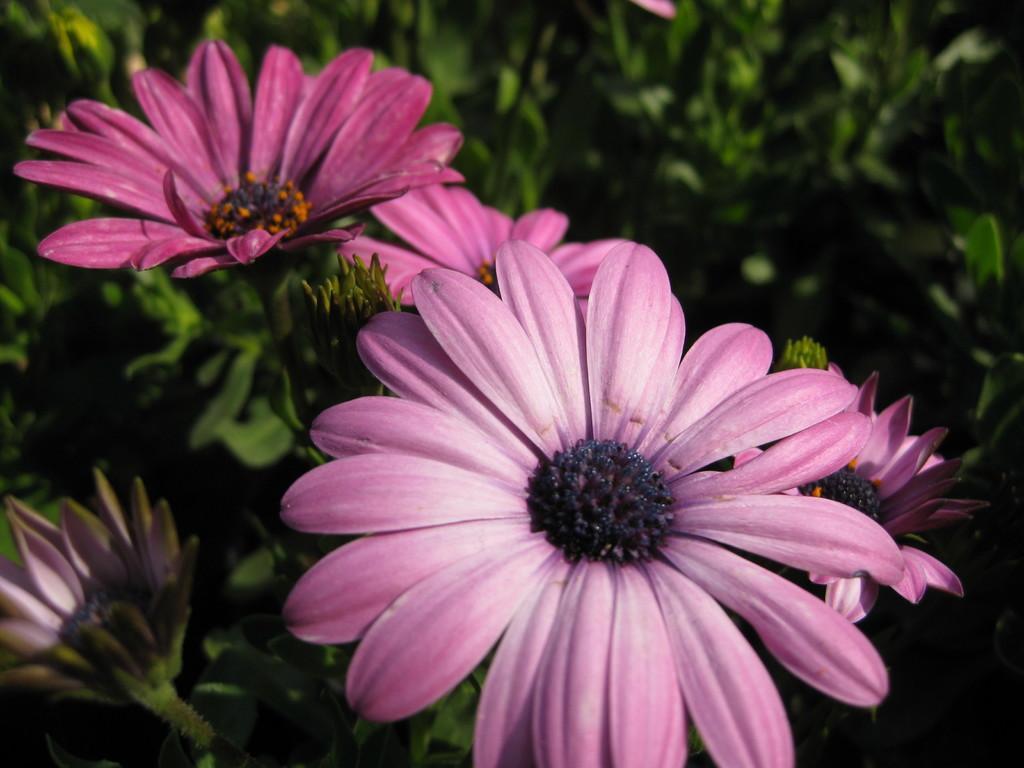Please provide a concise description of this image. In this image we can see flowers and buds to the plants. 